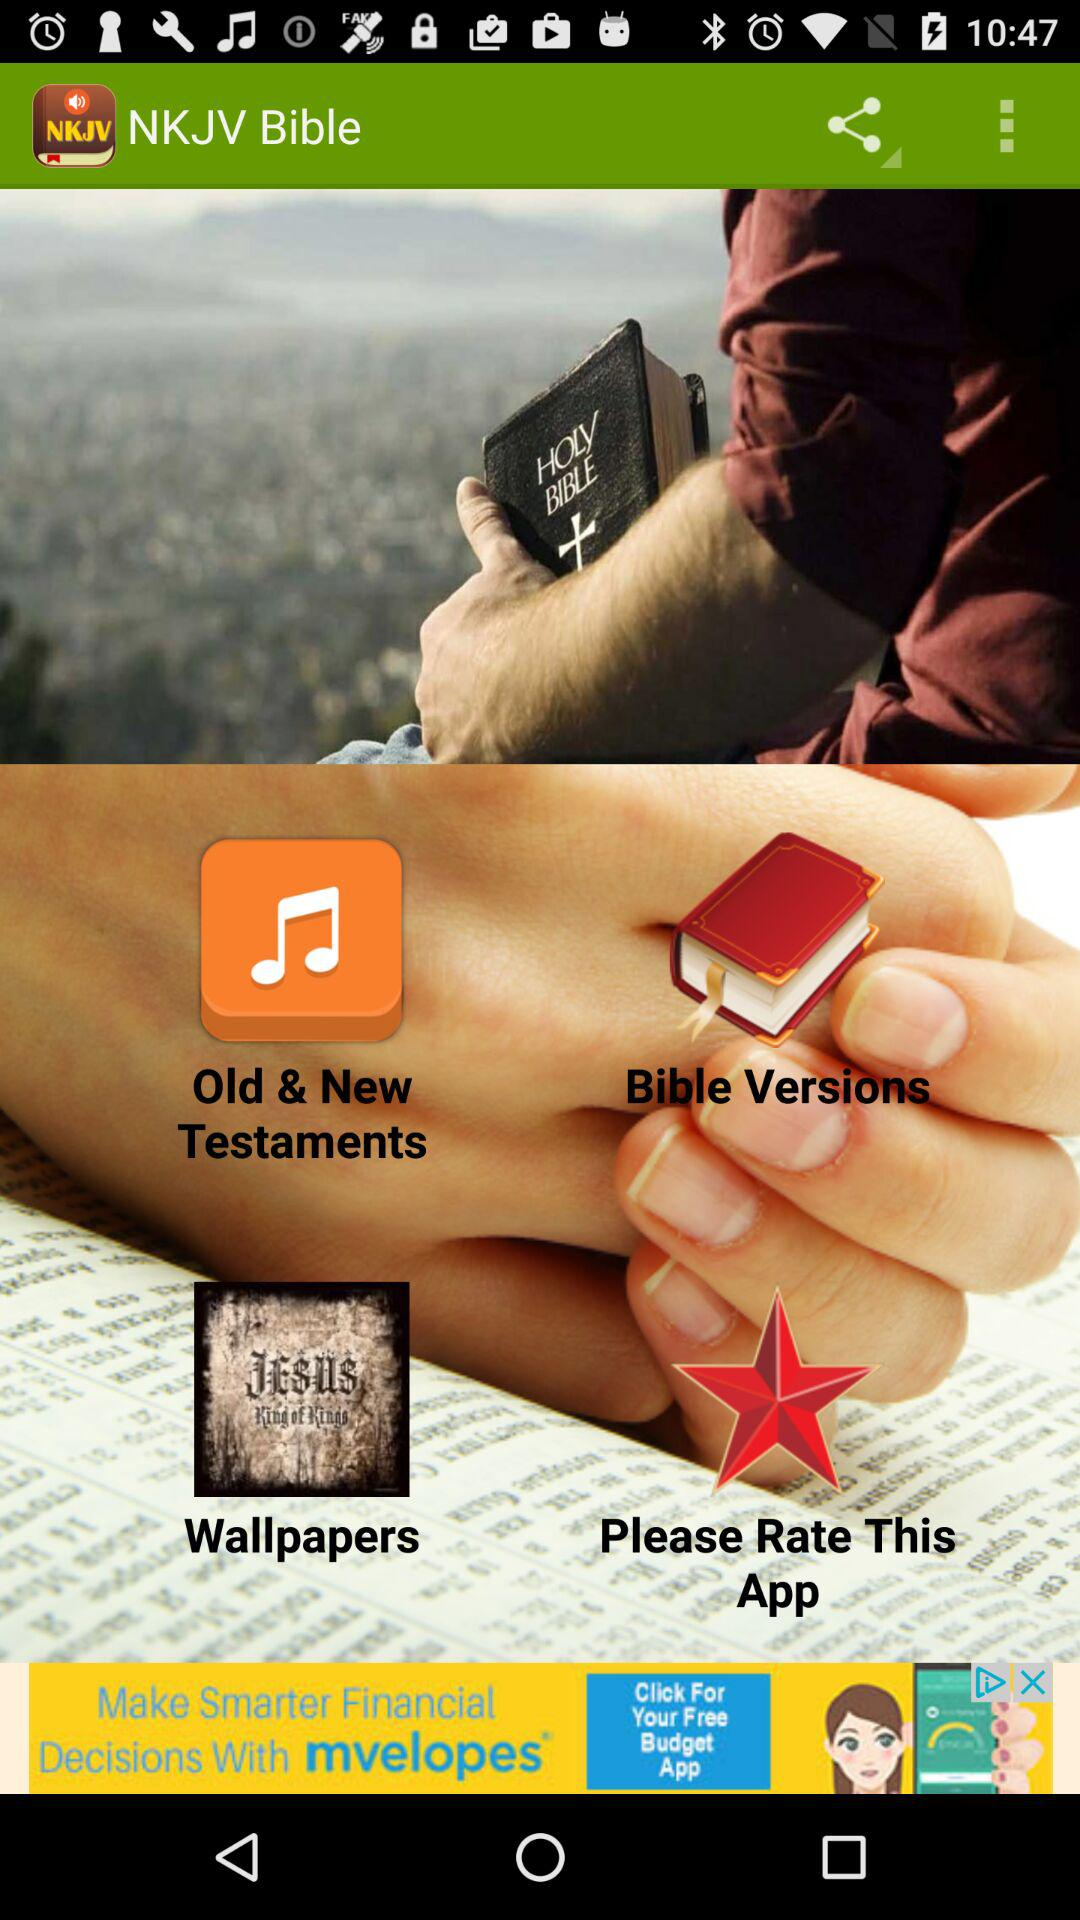What is the application name? The application name is "NKJV Bible". 